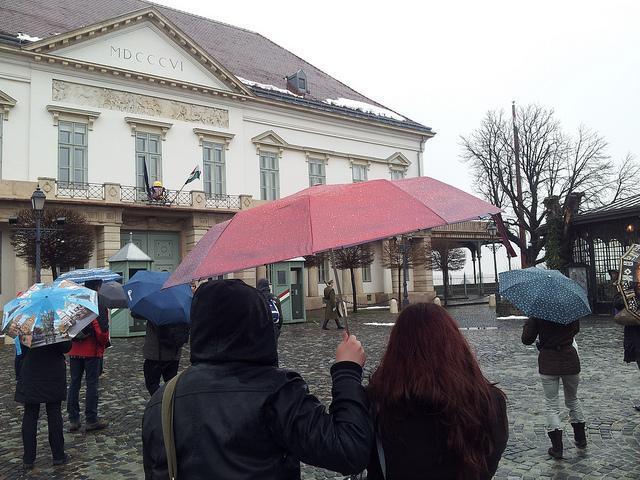How many umbrellas are there?
Give a very brief answer. 4. How many people can you see?
Give a very brief answer. 6. 